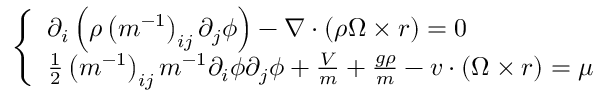Convert formula to latex. <formula><loc_0><loc_0><loc_500><loc_500>\left \{ \begin{array} { l } { \partial _ { i } \left ( \rho \left ( m ^ { - 1 } \right ) _ { i j } \partial _ { j } \phi \right ) - \nabla \cdot ( \rho \Omega \times r ) = 0 } \\ { \frac { 1 } { 2 } \left ( m ^ { - 1 } \right ) _ { i j } m ^ { - 1 } \partial _ { i } \phi \partial _ { j } \phi + \frac { V } { m } + \frac { g \rho } { m } - v \cdot ( \Omega \times r ) = \mu } \end{array}</formula> 